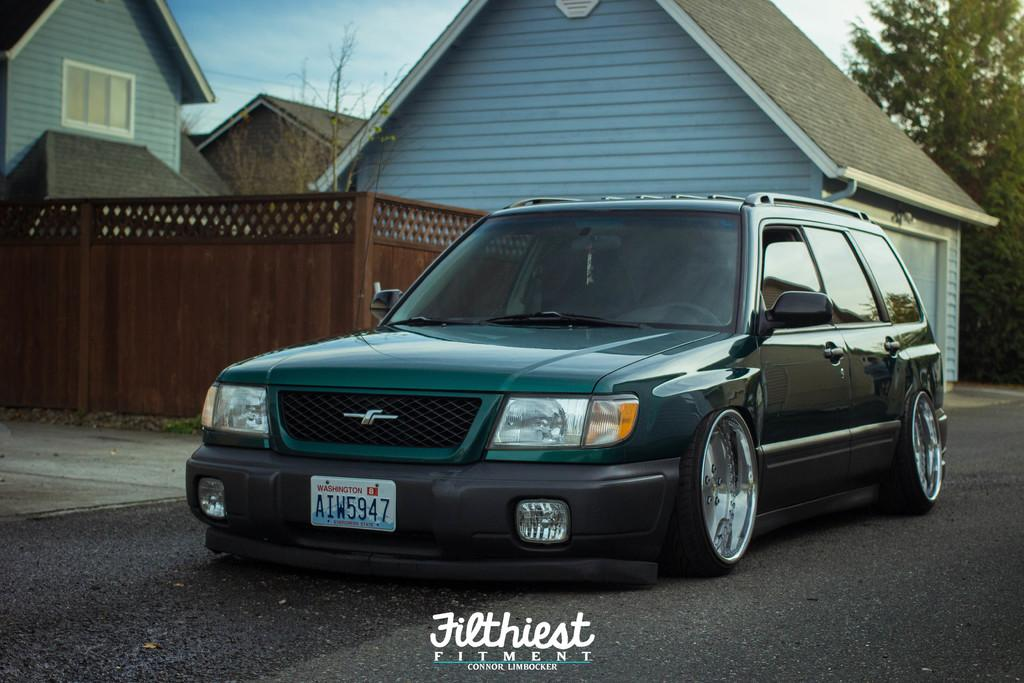What type of structures can be seen in the image? There are houses in the image. What other natural elements are present in the image? There are trees in the image. What mode of transportation can be seen on the road in the image? There is a car on the road in the image. How would you describe the sky in the image? The sky is blue and cloudy in the image. Is there any text present in the image? Yes, there is text at the bottom of the image. Can you tell me how many owls are sitting on the lawyer's tray in the image? There are no owls or lawyers present in the image; it features houses, trees, a car, a blue and cloudy sky, and text at the bottom. 